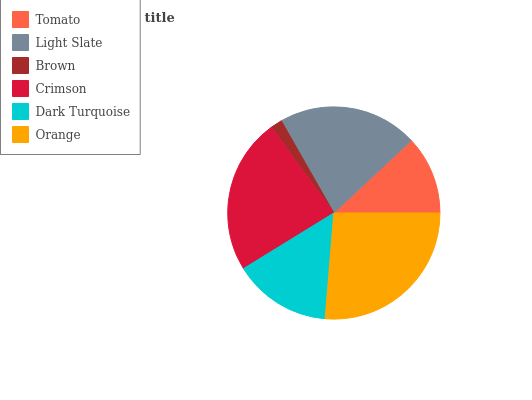Is Brown the minimum?
Answer yes or no. Yes. Is Orange the maximum?
Answer yes or no. Yes. Is Light Slate the minimum?
Answer yes or no. No. Is Light Slate the maximum?
Answer yes or no. No. Is Light Slate greater than Tomato?
Answer yes or no. Yes. Is Tomato less than Light Slate?
Answer yes or no. Yes. Is Tomato greater than Light Slate?
Answer yes or no. No. Is Light Slate less than Tomato?
Answer yes or no. No. Is Light Slate the high median?
Answer yes or no. Yes. Is Dark Turquoise the low median?
Answer yes or no. Yes. Is Crimson the high median?
Answer yes or no. No. Is Orange the low median?
Answer yes or no. No. 